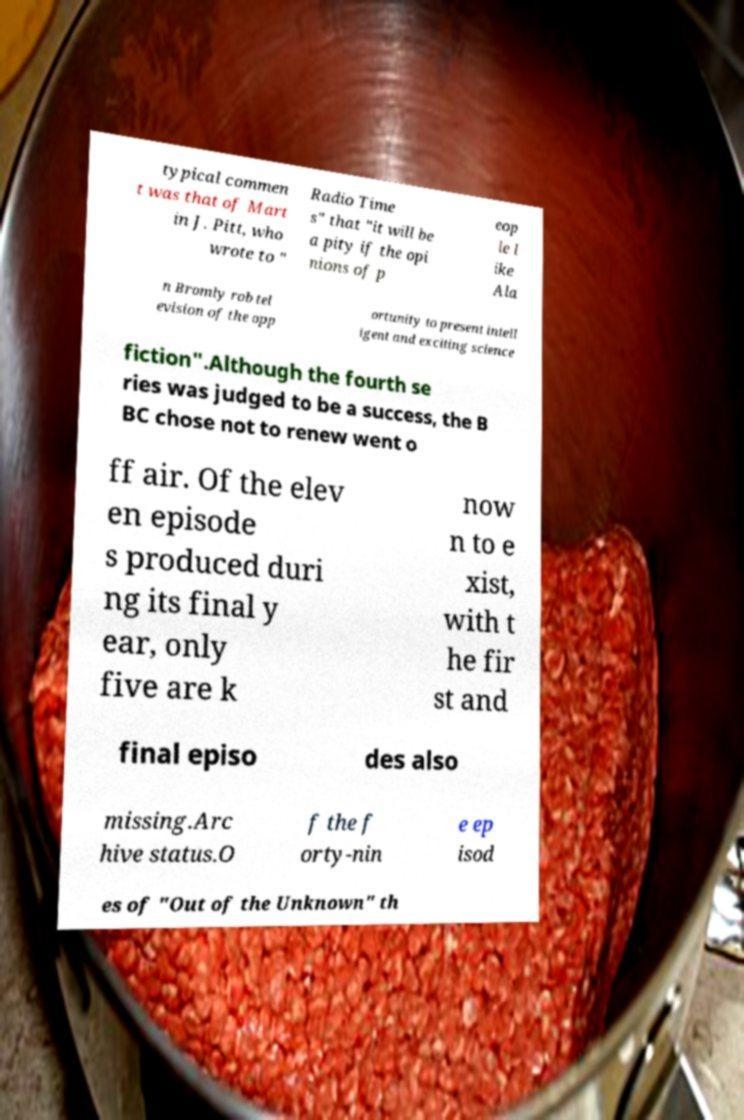Please read and relay the text visible in this image. What does it say? typical commen t was that of Mart in J. Pitt, who wrote to " Radio Time s" that "it will be a pity if the opi nions of p eop le l ike Ala n Bromly rob tel evision of the opp ortunity to present intell igent and exciting science fiction".Although the fourth se ries was judged to be a success, the B BC chose not to renew went o ff air. Of the elev en episode s produced duri ng its final y ear, only five are k now n to e xist, with t he fir st and final episo des also missing.Arc hive status.O f the f orty-nin e ep isod es of "Out of the Unknown" th 